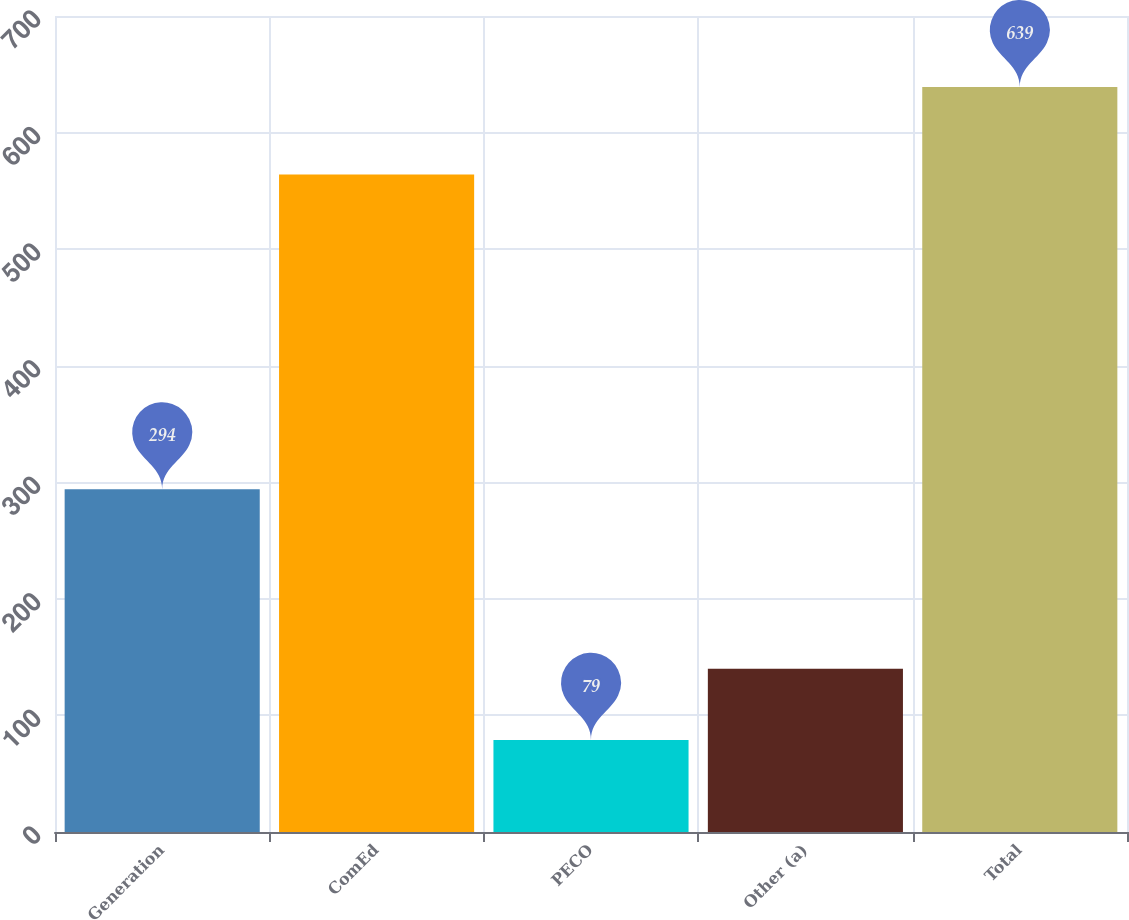Convert chart to OTSL. <chart><loc_0><loc_0><loc_500><loc_500><bar_chart><fcel>Generation<fcel>ComEd<fcel>PECO<fcel>Other (a)<fcel>Total<nl><fcel>294<fcel>564<fcel>79<fcel>140<fcel>639<nl></chart> 